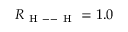<formula> <loc_0><loc_0><loc_500><loc_500>R _ { H - - H } = 1 . 0</formula> 